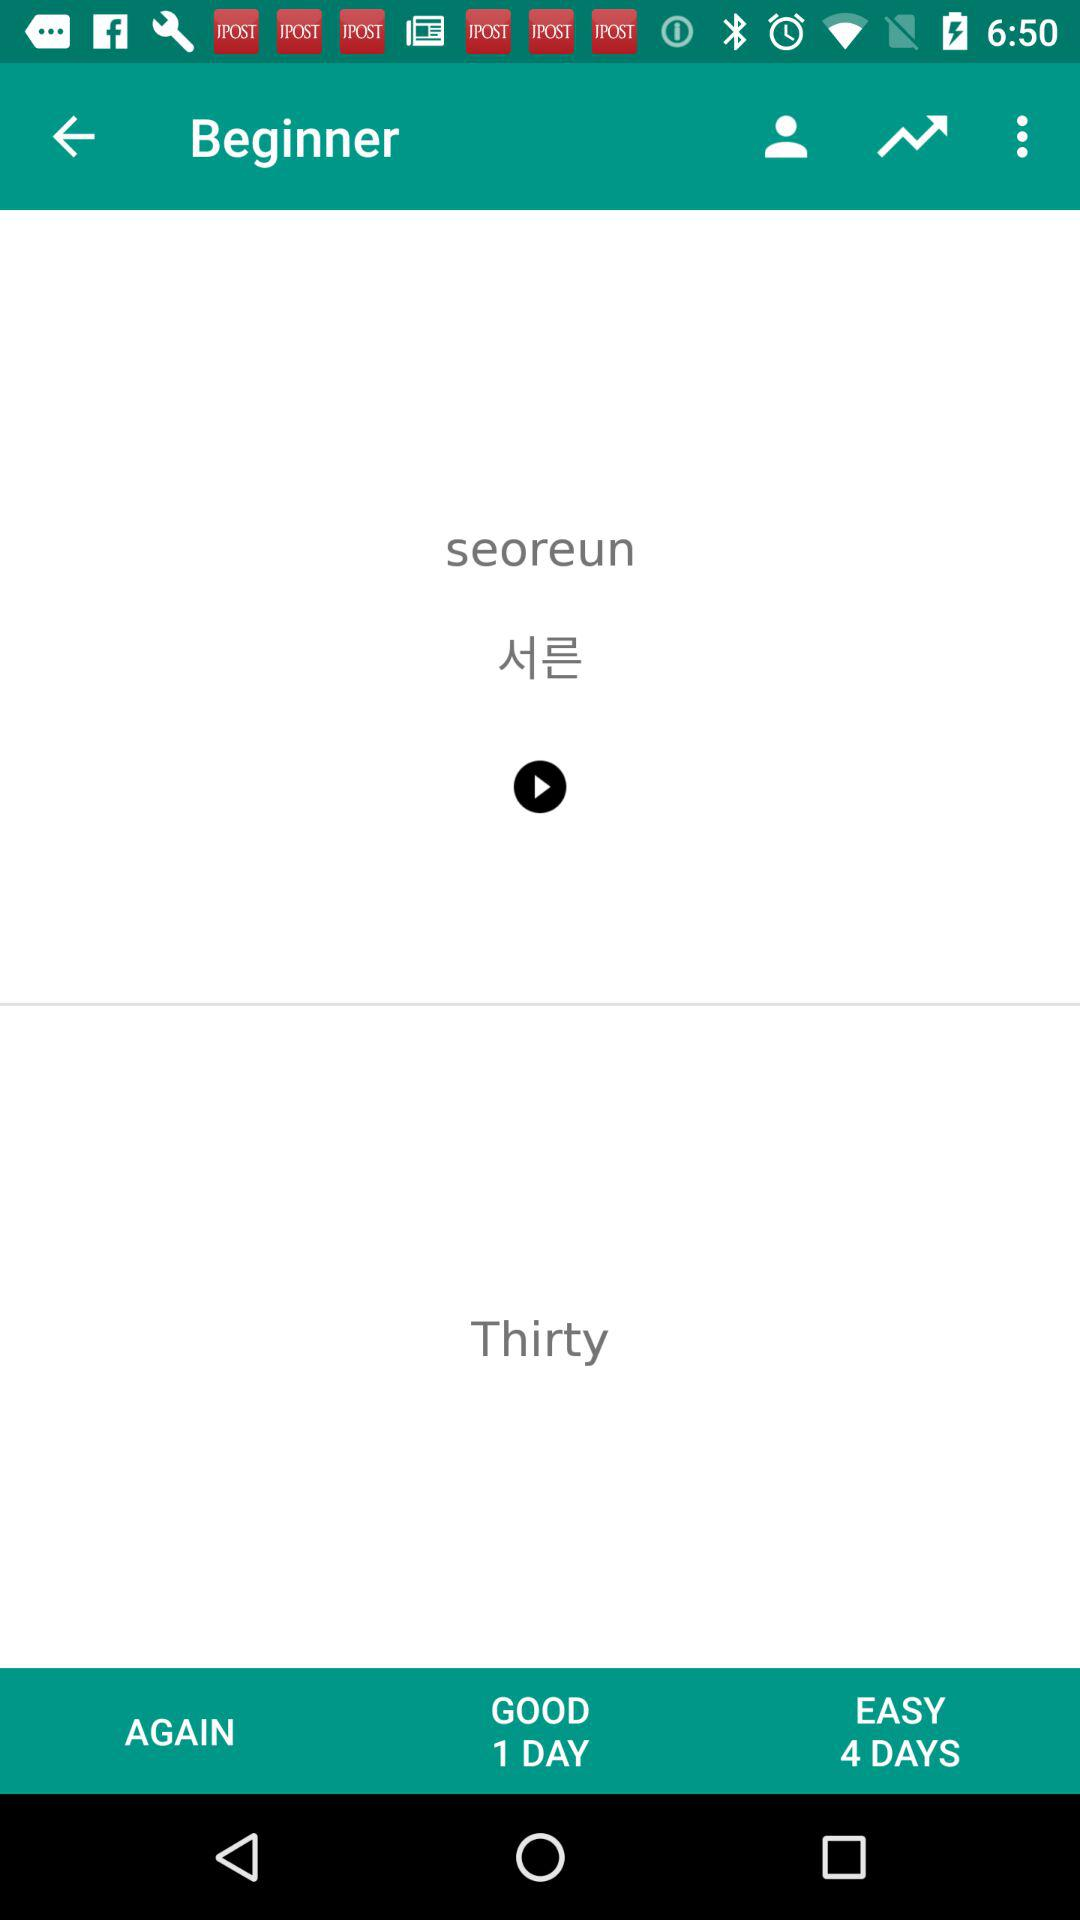At which level am I? You are at the beginner level. 